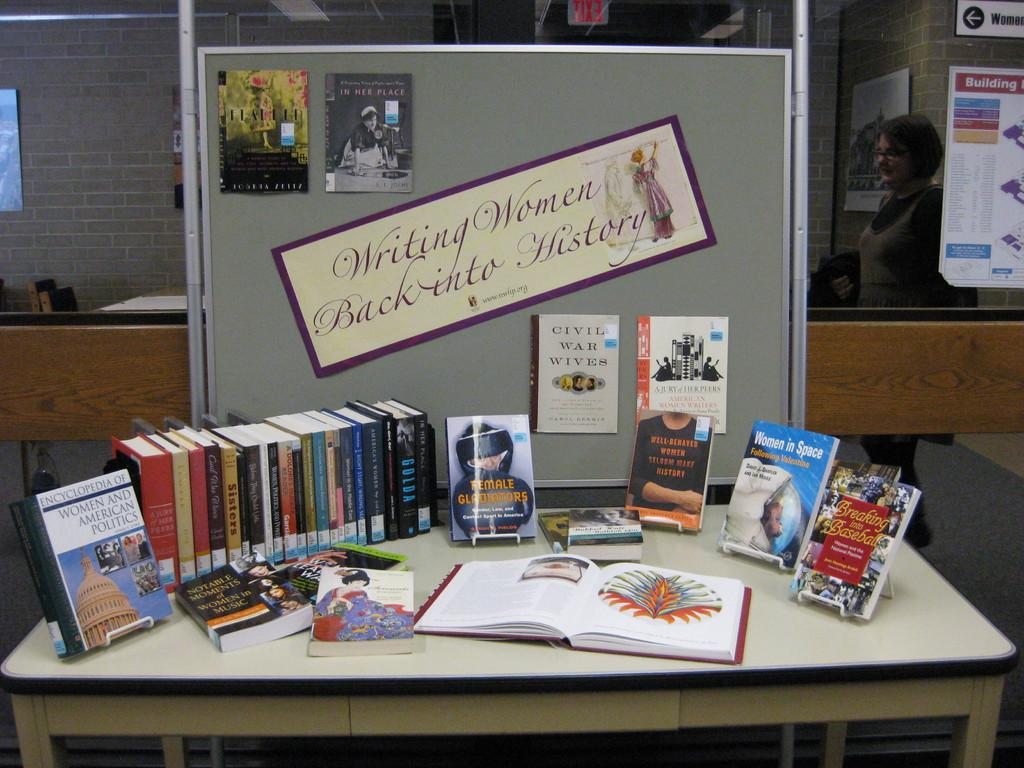What is the main object in the center of the image? There is a table in the center of the image. What items can be seen on the table? There are books and paper on the table. What can be seen in the background of the image? There is a brick wall, a board, a glass object, a sign board, another table, a chair, and a person standing in the background of the image. What type of chalk is being used to write on the board in the background of the image? There is no chalk visible in the image, and no writing is being done on the board. Can you tell me which country the map on the board in the background of the image represents? There is no map present on the board or in the image. 